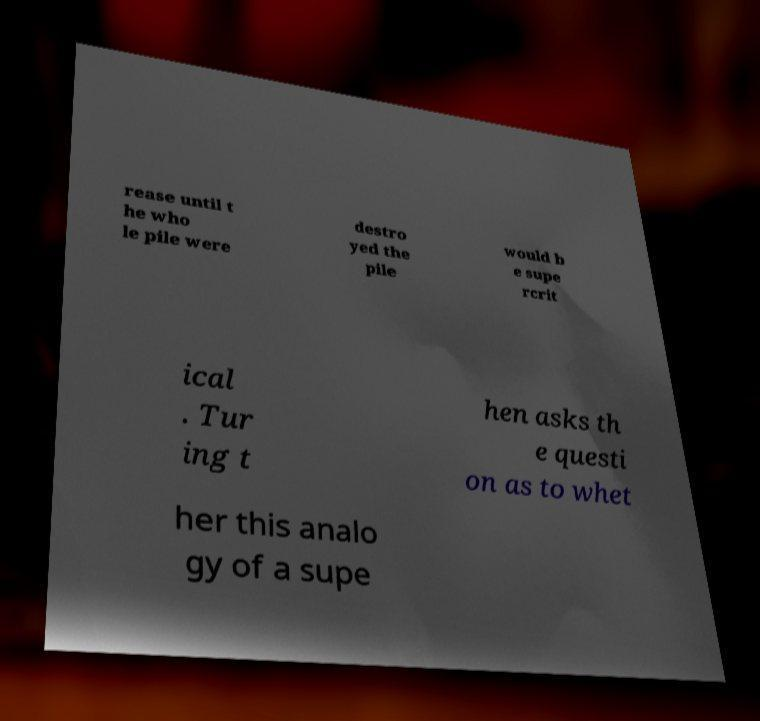Please identify and transcribe the text found in this image. rease until t he who le pile were destro yed the pile would b e supe rcrit ical . Tur ing t hen asks th e questi on as to whet her this analo gy of a supe 